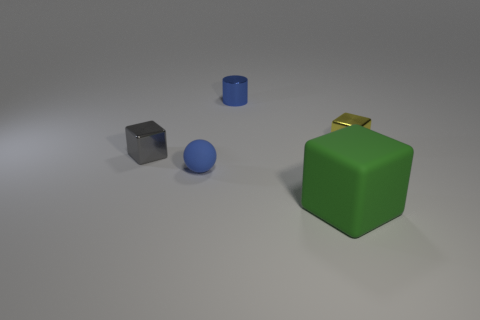Add 2 tiny green rubber balls. How many objects exist? 7 Subtract all cubes. How many objects are left? 2 Subtract all tiny brown cylinders. Subtract all large green matte objects. How many objects are left? 4 Add 4 blue cylinders. How many blue cylinders are left? 5 Add 2 large gray matte balls. How many large gray matte balls exist? 2 Subtract 0 purple cylinders. How many objects are left? 5 